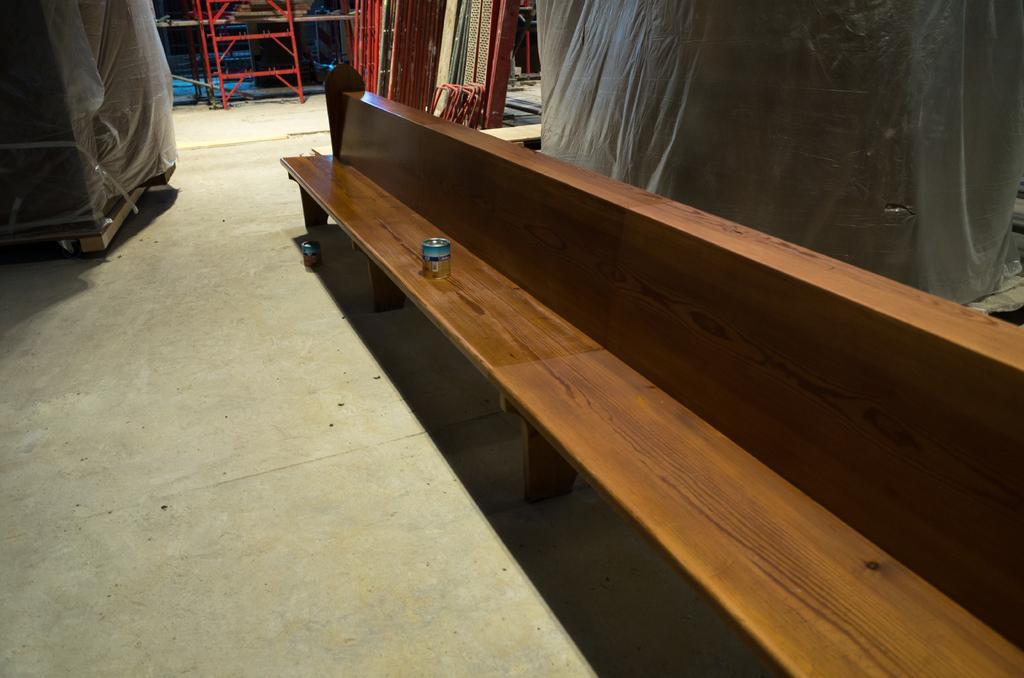In one or two sentences, can you explain what this image depicts? On the right side it's a wooden bench, there are other things at here. 